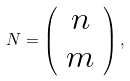Convert formula to latex. <formula><loc_0><loc_0><loc_500><loc_500>N = \left ( \begin{array} { c c } { n } \\ { m } \end{array} \right ) ,</formula> 